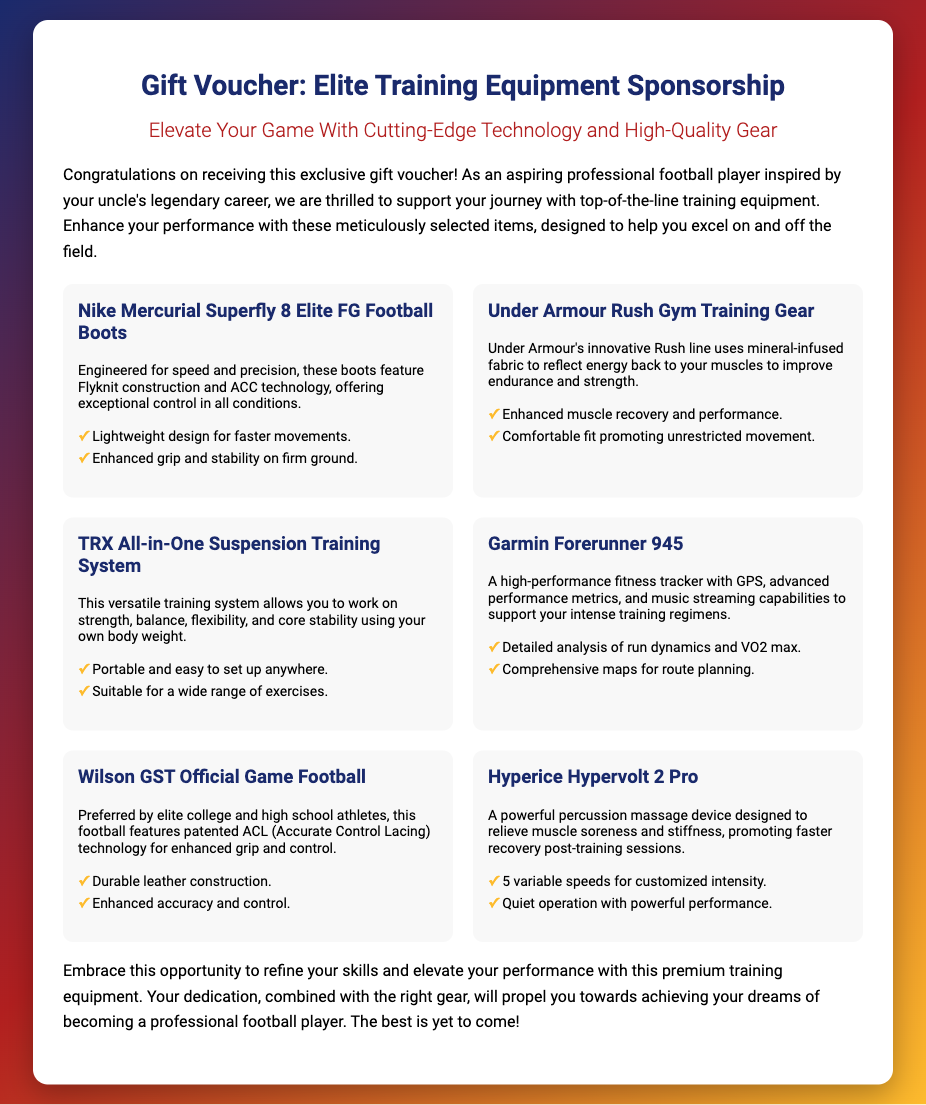What is the title of the voucher? The title of the voucher is featured prominently at the top of the document.
Answer: Elite Training Equipment Sponsorship Gift Voucher What brand is associated with the football boots? The football boots mentioned in the document specifically identify their brand.
Answer: Nike What technology is used in Under Armour's Rush Gym Training Gear? The document explains that the gym gear uses specialized fabric to enhance performance.
Answer: Mineral-infused fabric What performance metric does the Garmin Forerunner 945 track? The fitness tracker includes several advanced metrics, one of which is commonly highlighted.
Answer: VO2 max How many items are listed in the voucher? The document contains a grid of items, which can be counted.
Answer: Six What feature of the TRX training system allows exercise anywhere? The document mentions a specific quality of the TRX system that supports its versatility.
Answer: Portable What does the Hypervolt 2 Pro do? The item description provides insight into the function of the device included in the voucher.
Answer: Relieve muscle soreness What kind of material is the Wilson GST Official Game Football made of? The document provides the construction material used for the football.
Answer: Durable leather What does the voucher encourage you to do? The closing remark of the document implies a specific action or mindset encouraged.
Answer: Refine your skills 